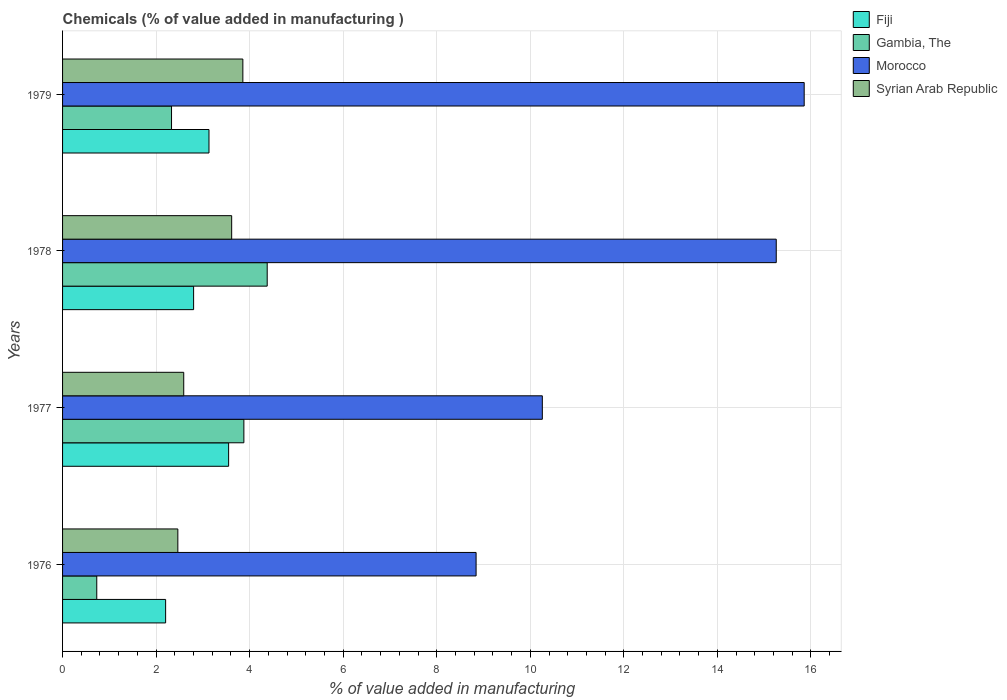How many groups of bars are there?
Give a very brief answer. 4. Are the number of bars on each tick of the Y-axis equal?
Your answer should be compact. Yes. What is the label of the 1st group of bars from the top?
Offer a very short reply. 1979. What is the value added in manufacturing chemicals in Morocco in 1977?
Your answer should be compact. 10.26. Across all years, what is the maximum value added in manufacturing chemicals in Morocco?
Keep it short and to the point. 15.86. Across all years, what is the minimum value added in manufacturing chemicals in Morocco?
Provide a short and direct response. 8.84. In which year was the value added in manufacturing chemicals in Morocco maximum?
Make the answer very short. 1979. In which year was the value added in manufacturing chemicals in Fiji minimum?
Your answer should be compact. 1976. What is the total value added in manufacturing chemicals in Syrian Arab Republic in the graph?
Your answer should be compact. 12.53. What is the difference between the value added in manufacturing chemicals in Gambia, The in 1977 and that in 1979?
Offer a terse response. 1.55. What is the difference between the value added in manufacturing chemicals in Syrian Arab Republic in 1978 and the value added in manufacturing chemicals in Fiji in 1977?
Your answer should be compact. 0.07. What is the average value added in manufacturing chemicals in Gambia, The per year?
Your answer should be compact. 2.83. In the year 1977, what is the difference between the value added in manufacturing chemicals in Morocco and value added in manufacturing chemicals in Syrian Arab Republic?
Provide a succinct answer. 7.67. What is the ratio of the value added in manufacturing chemicals in Gambia, The in 1977 to that in 1979?
Offer a very short reply. 1.66. What is the difference between the highest and the second highest value added in manufacturing chemicals in Syrian Arab Republic?
Your answer should be compact. 0.24. What is the difference between the highest and the lowest value added in manufacturing chemicals in Fiji?
Offer a terse response. 1.35. In how many years, is the value added in manufacturing chemicals in Fiji greater than the average value added in manufacturing chemicals in Fiji taken over all years?
Keep it short and to the point. 2. Is the sum of the value added in manufacturing chemicals in Fiji in 1976 and 1977 greater than the maximum value added in manufacturing chemicals in Gambia, The across all years?
Your answer should be compact. Yes. Is it the case that in every year, the sum of the value added in manufacturing chemicals in Fiji and value added in manufacturing chemicals in Syrian Arab Republic is greater than the sum of value added in manufacturing chemicals in Morocco and value added in manufacturing chemicals in Gambia, The?
Ensure brevity in your answer.  No. What does the 2nd bar from the top in 1977 represents?
Offer a very short reply. Morocco. What does the 2nd bar from the bottom in 1977 represents?
Ensure brevity in your answer.  Gambia, The. Is it the case that in every year, the sum of the value added in manufacturing chemicals in Syrian Arab Republic and value added in manufacturing chemicals in Fiji is greater than the value added in manufacturing chemicals in Morocco?
Your response must be concise. No. How many years are there in the graph?
Keep it short and to the point. 4. Where does the legend appear in the graph?
Keep it short and to the point. Top right. How are the legend labels stacked?
Offer a very short reply. Vertical. What is the title of the graph?
Offer a very short reply. Chemicals (% of value added in manufacturing ). What is the label or title of the X-axis?
Give a very brief answer. % of value added in manufacturing. What is the label or title of the Y-axis?
Offer a very short reply. Years. What is the % of value added in manufacturing in Fiji in 1976?
Provide a short and direct response. 2.2. What is the % of value added in manufacturing in Gambia, The in 1976?
Give a very brief answer. 0.73. What is the % of value added in manufacturing in Morocco in 1976?
Ensure brevity in your answer.  8.84. What is the % of value added in manufacturing of Syrian Arab Republic in 1976?
Provide a short and direct response. 2.46. What is the % of value added in manufacturing of Fiji in 1977?
Provide a succinct answer. 3.55. What is the % of value added in manufacturing in Gambia, The in 1977?
Ensure brevity in your answer.  3.88. What is the % of value added in manufacturing of Morocco in 1977?
Make the answer very short. 10.26. What is the % of value added in manufacturing of Syrian Arab Republic in 1977?
Your answer should be compact. 2.59. What is the % of value added in manufacturing in Fiji in 1978?
Ensure brevity in your answer.  2.8. What is the % of value added in manufacturing of Gambia, The in 1978?
Provide a succinct answer. 4.38. What is the % of value added in manufacturing of Morocco in 1978?
Your answer should be compact. 15.26. What is the % of value added in manufacturing of Syrian Arab Republic in 1978?
Ensure brevity in your answer.  3.62. What is the % of value added in manufacturing in Fiji in 1979?
Provide a succinct answer. 3.13. What is the % of value added in manufacturing of Gambia, The in 1979?
Provide a short and direct response. 2.33. What is the % of value added in manufacturing of Morocco in 1979?
Make the answer very short. 15.86. What is the % of value added in manufacturing in Syrian Arab Republic in 1979?
Keep it short and to the point. 3.85. Across all years, what is the maximum % of value added in manufacturing in Fiji?
Offer a very short reply. 3.55. Across all years, what is the maximum % of value added in manufacturing in Gambia, The?
Your answer should be compact. 4.38. Across all years, what is the maximum % of value added in manufacturing of Morocco?
Ensure brevity in your answer.  15.86. Across all years, what is the maximum % of value added in manufacturing of Syrian Arab Republic?
Give a very brief answer. 3.85. Across all years, what is the minimum % of value added in manufacturing in Fiji?
Provide a succinct answer. 2.2. Across all years, what is the minimum % of value added in manufacturing in Gambia, The?
Offer a very short reply. 0.73. Across all years, what is the minimum % of value added in manufacturing in Morocco?
Provide a short and direct response. 8.84. Across all years, what is the minimum % of value added in manufacturing in Syrian Arab Republic?
Provide a succinct answer. 2.46. What is the total % of value added in manufacturing of Fiji in the graph?
Your response must be concise. 11.69. What is the total % of value added in manufacturing in Gambia, The in the graph?
Provide a succinct answer. 11.31. What is the total % of value added in manufacturing in Morocco in the graph?
Keep it short and to the point. 50.21. What is the total % of value added in manufacturing in Syrian Arab Republic in the graph?
Give a very brief answer. 12.53. What is the difference between the % of value added in manufacturing in Fiji in 1976 and that in 1977?
Offer a very short reply. -1.35. What is the difference between the % of value added in manufacturing of Gambia, The in 1976 and that in 1977?
Provide a succinct answer. -3.15. What is the difference between the % of value added in manufacturing of Morocco in 1976 and that in 1977?
Your answer should be compact. -1.42. What is the difference between the % of value added in manufacturing of Syrian Arab Republic in 1976 and that in 1977?
Offer a very short reply. -0.13. What is the difference between the % of value added in manufacturing of Fiji in 1976 and that in 1978?
Provide a succinct answer. -0.6. What is the difference between the % of value added in manufacturing in Gambia, The in 1976 and that in 1978?
Ensure brevity in your answer.  -3.64. What is the difference between the % of value added in manufacturing in Morocco in 1976 and that in 1978?
Provide a succinct answer. -6.42. What is the difference between the % of value added in manufacturing in Syrian Arab Republic in 1976 and that in 1978?
Ensure brevity in your answer.  -1.15. What is the difference between the % of value added in manufacturing in Fiji in 1976 and that in 1979?
Your response must be concise. -0.93. What is the difference between the % of value added in manufacturing of Gambia, The in 1976 and that in 1979?
Provide a succinct answer. -1.6. What is the difference between the % of value added in manufacturing in Morocco in 1976 and that in 1979?
Your response must be concise. -7.01. What is the difference between the % of value added in manufacturing in Syrian Arab Republic in 1976 and that in 1979?
Provide a short and direct response. -1.39. What is the difference between the % of value added in manufacturing in Fiji in 1977 and that in 1978?
Make the answer very short. 0.75. What is the difference between the % of value added in manufacturing of Gambia, The in 1977 and that in 1978?
Your response must be concise. -0.5. What is the difference between the % of value added in manufacturing of Morocco in 1977 and that in 1978?
Keep it short and to the point. -5. What is the difference between the % of value added in manufacturing in Syrian Arab Republic in 1977 and that in 1978?
Keep it short and to the point. -1.02. What is the difference between the % of value added in manufacturing of Fiji in 1977 and that in 1979?
Keep it short and to the point. 0.42. What is the difference between the % of value added in manufacturing in Gambia, The in 1977 and that in 1979?
Provide a short and direct response. 1.55. What is the difference between the % of value added in manufacturing of Morocco in 1977 and that in 1979?
Offer a very short reply. -5.6. What is the difference between the % of value added in manufacturing in Syrian Arab Republic in 1977 and that in 1979?
Keep it short and to the point. -1.26. What is the difference between the % of value added in manufacturing of Fiji in 1978 and that in 1979?
Give a very brief answer. -0.33. What is the difference between the % of value added in manufacturing of Gambia, The in 1978 and that in 1979?
Give a very brief answer. 2.05. What is the difference between the % of value added in manufacturing in Morocco in 1978 and that in 1979?
Offer a terse response. -0.6. What is the difference between the % of value added in manufacturing of Syrian Arab Republic in 1978 and that in 1979?
Give a very brief answer. -0.24. What is the difference between the % of value added in manufacturing of Fiji in 1976 and the % of value added in manufacturing of Gambia, The in 1977?
Give a very brief answer. -1.67. What is the difference between the % of value added in manufacturing of Fiji in 1976 and the % of value added in manufacturing of Morocco in 1977?
Offer a very short reply. -8.05. What is the difference between the % of value added in manufacturing in Fiji in 1976 and the % of value added in manufacturing in Syrian Arab Republic in 1977?
Offer a terse response. -0.39. What is the difference between the % of value added in manufacturing of Gambia, The in 1976 and the % of value added in manufacturing of Morocco in 1977?
Your response must be concise. -9.53. What is the difference between the % of value added in manufacturing of Gambia, The in 1976 and the % of value added in manufacturing of Syrian Arab Republic in 1977?
Your answer should be compact. -1.86. What is the difference between the % of value added in manufacturing of Morocco in 1976 and the % of value added in manufacturing of Syrian Arab Republic in 1977?
Make the answer very short. 6.25. What is the difference between the % of value added in manufacturing of Fiji in 1976 and the % of value added in manufacturing of Gambia, The in 1978?
Offer a very short reply. -2.17. What is the difference between the % of value added in manufacturing in Fiji in 1976 and the % of value added in manufacturing in Morocco in 1978?
Give a very brief answer. -13.06. What is the difference between the % of value added in manufacturing in Fiji in 1976 and the % of value added in manufacturing in Syrian Arab Republic in 1978?
Give a very brief answer. -1.41. What is the difference between the % of value added in manufacturing in Gambia, The in 1976 and the % of value added in manufacturing in Morocco in 1978?
Your answer should be compact. -14.53. What is the difference between the % of value added in manufacturing in Gambia, The in 1976 and the % of value added in manufacturing in Syrian Arab Republic in 1978?
Keep it short and to the point. -2.88. What is the difference between the % of value added in manufacturing in Morocco in 1976 and the % of value added in manufacturing in Syrian Arab Republic in 1978?
Your response must be concise. 5.23. What is the difference between the % of value added in manufacturing in Fiji in 1976 and the % of value added in manufacturing in Gambia, The in 1979?
Offer a very short reply. -0.13. What is the difference between the % of value added in manufacturing of Fiji in 1976 and the % of value added in manufacturing of Morocco in 1979?
Provide a succinct answer. -13.65. What is the difference between the % of value added in manufacturing in Fiji in 1976 and the % of value added in manufacturing in Syrian Arab Republic in 1979?
Keep it short and to the point. -1.65. What is the difference between the % of value added in manufacturing in Gambia, The in 1976 and the % of value added in manufacturing in Morocco in 1979?
Give a very brief answer. -15.12. What is the difference between the % of value added in manufacturing of Gambia, The in 1976 and the % of value added in manufacturing of Syrian Arab Republic in 1979?
Provide a short and direct response. -3.12. What is the difference between the % of value added in manufacturing in Morocco in 1976 and the % of value added in manufacturing in Syrian Arab Republic in 1979?
Offer a terse response. 4.99. What is the difference between the % of value added in manufacturing of Fiji in 1977 and the % of value added in manufacturing of Gambia, The in 1978?
Your answer should be compact. -0.82. What is the difference between the % of value added in manufacturing in Fiji in 1977 and the % of value added in manufacturing in Morocco in 1978?
Your answer should be very brief. -11.71. What is the difference between the % of value added in manufacturing in Fiji in 1977 and the % of value added in manufacturing in Syrian Arab Republic in 1978?
Your answer should be very brief. -0.07. What is the difference between the % of value added in manufacturing in Gambia, The in 1977 and the % of value added in manufacturing in Morocco in 1978?
Your answer should be compact. -11.38. What is the difference between the % of value added in manufacturing in Gambia, The in 1977 and the % of value added in manufacturing in Syrian Arab Republic in 1978?
Provide a short and direct response. 0.26. What is the difference between the % of value added in manufacturing in Morocco in 1977 and the % of value added in manufacturing in Syrian Arab Republic in 1978?
Your answer should be compact. 6.64. What is the difference between the % of value added in manufacturing of Fiji in 1977 and the % of value added in manufacturing of Gambia, The in 1979?
Make the answer very short. 1.22. What is the difference between the % of value added in manufacturing in Fiji in 1977 and the % of value added in manufacturing in Morocco in 1979?
Give a very brief answer. -12.31. What is the difference between the % of value added in manufacturing in Fiji in 1977 and the % of value added in manufacturing in Syrian Arab Republic in 1979?
Make the answer very short. -0.3. What is the difference between the % of value added in manufacturing of Gambia, The in 1977 and the % of value added in manufacturing of Morocco in 1979?
Give a very brief answer. -11.98. What is the difference between the % of value added in manufacturing of Gambia, The in 1977 and the % of value added in manufacturing of Syrian Arab Republic in 1979?
Your answer should be compact. 0.02. What is the difference between the % of value added in manufacturing in Morocco in 1977 and the % of value added in manufacturing in Syrian Arab Republic in 1979?
Make the answer very short. 6.4. What is the difference between the % of value added in manufacturing of Fiji in 1978 and the % of value added in manufacturing of Gambia, The in 1979?
Offer a very short reply. 0.47. What is the difference between the % of value added in manufacturing in Fiji in 1978 and the % of value added in manufacturing in Morocco in 1979?
Your answer should be very brief. -13.05. What is the difference between the % of value added in manufacturing of Fiji in 1978 and the % of value added in manufacturing of Syrian Arab Republic in 1979?
Your answer should be very brief. -1.05. What is the difference between the % of value added in manufacturing of Gambia, The in 1978 and the % of value added in manufacturing of Morocco in 1979?
Make the answer very short. -11.48. What is the difference between the % of value added in manufacturing of Gambia, The in 1978 and the % of value added in manufacturing of Syrian Arab Republic in 1979?
Offer a terse response. 0.52. What is the difference between the % of value added in manufacturing of Morocco in 1978 and the % of value added in manufacturing of Syrian Arab Republic in 1979?
Ensure brevity in your answer.  11.4. What is the average % of value added in manufacturing in Fiji per year?
Your response must be concise. 2.92. What is the average % of value added in manufacturing of Gambia, The per year?
Keep it short and to the point. 2.83. What is the average % of value added in manufacturing in Morocco per year?
Keep it short and to the point. 12.55. What is the average % of value added in manufacturing in Syrian Arab Republic per year?
Ensure brevity in your answer.  3.13. In the year 1976, what is the difference between the % of value added in manufacturing in Fiji and % of value added in manufacturing in Gambia, The?
Provide a short and direct response. 1.47. In the year 1976, what is the difference between the % of value added in manufacturing of Fiji and % of value added in manufacturing of Morocco?
Make the answer very short. -6.64. In the year 1976, what is the difference between the % of value added in manufacturing of Fiji and % of value added in manufacturing of Syrian Arab Republic?
Offer a terse response. -0.26. In the year 1976, what is the difference between the % of value added in manufacturing in Gambia, The and % of value added in manufacturing in Morocco?
Offer a terse response. -8.11. In the year 1976, what is the difference between the % of value added in manufacturing in Gambia, The and % of value added in manufacturing in Syrian Arab Republic?
Give a very brief answer. -1.73. In the year 1976, what is the difference between the % of value added in manufacturing of Morocco and % of value added in manufacturing of Syrian Arab Republic?
Keep it short and to the point. 6.38. In the year 1977, what is the difference between the % of value added in manufacturing of Fiji and % of value added in manufacturing of Gambia, The?
Your response must be concise. -0.33. In the year 1977, what is the difference between the % of value added in manufacturing of Fiji and % of value added in manufacturing of Morocco?
Offer a very short reply. -6.71. In the year 1977, what is the difference between the % of value added in manufacturing of Fiji and % of value added in manufacturing of Syrian Arab Republic?
Offer a terse response. 0.96. In the year 1977, what is the difference between the % of value added in manufacturing of Gambia, The and % of value added in manufacturing of Morocco?
Provide a succinct answer. -6.38. In the year 1977, what is the difference between the % of value added in manufacturing in Gambia, The and % of value added in manufacturing in Syrian Arab Republic?
Give a very brief answer. 1.29. In the year 1977, what is the difference between the % of value added in manufacturing in Morocco and % of value added in manufacturing in Syrian Arab Republic?
Make the answer very short. 7.67. In the year 1978, what is the difference between the % of value added in manufacturing in Fiji and % of value added in manufacturing in Gambia, The?
Your answer should be compact. -1.57. In the year 1978, what is the difference between the % of value added in manufacturing of Fiji and % of value added in manufacturing of Morocco?
Provide a succinct answer. -12.46. In the year 1978, what is the difference between the % of value added in manufacturing in Fiji and % of value added in manufacturing in Syrian Arab Republic?
Make the answer very short. -0.81. In the year 1978, what is the difference between the % of value added in manufacturing of Gambia, The and % of value added in manufacturing of Morocco?
Keep it short and to the point. -10.88. In the year 1978, what is the difference between the % of value added in manufacturing of Gambia, The and % of value added in manufacturing of Syrian Arab Republic?
Your answer should be compact. 0.76. In the year 1978, what is the difference between the % of value added in manufacturing of Morocco and % of value added in manufacturing of Syrian Arab Republic?
Provide a short and direct response. 11.64. In the year 1979, what is the difference between the % of value added in manufacturing in Fiji and % of value added in manufacturing in Gambia, The?
Give a very brief answer. 0.8. In the year 1979, what is the difference between the % of value added in manufacturing in Fiji and % of value added in manufacturing in Morocco?
Your answer should be compact. -12.73. In the year 1979, what is the difference between the % of value added in manufacturing in Fiji and % of value added in manufacturing in Syrian Arab Republic?
Make the answer very short. -0.72. In the year 1979, what is the difference between the % of value added in manufacturing of Gambia, The and % of value added in manufacturing of Morocco?
Your answer should be very brief. -13.53. In the year 1979, what is the difference between the % of value added in manufacturing in Gambia, The and % of value added in manufacturing in Syrian Arab Republic?
Your response must be concise. -1.53. In the year 1979, what is the difference between the % of value added in manufacturing of Morocco and % of value added in manufacturing of Syrian Arab Republic?
Provide a succinct answer. 12. What is the ratio of the % of value added in manufacturing in Fiji in 1976 to that in 1977?
Provide a succinct answer. 0.62. What is the ratio of the % of value added in manufacturing of Gambia, The in 1976 to that in 1977?
Your response must be concise. 0.19. What is the ratio of the % of value added in manufacturing of Morocco in 1976 to that in 1977?
Your answer should be very brief. 0.86. What is the ratio of the % of value added in manufacturing of Syrian Arab Republic in 1976 to that in 1977?
Your response must be concise. 0.95. What is the ratio of the % of value added in manufacturing in Fiji in 1976 to that in 1978?
Provide a succinct answer. 0.79. What is the ratio of the % of value added in manufacturing in Gambia, The in 1976 to that in 1978?
Your answer should be very brief. 0.17. What is the ratio of the % of value added in manufacturing in Morocco in 1976 to that in 1978?
Offer a very short reply. 0.58. What is the ratio of the % of value added in manufacturing of Syrian Arab Republic in 1976 to that in 1978?
Your answer should be very brief. 0.68. What is the ratio of the % of value added in manufacturing in Fiji in 1976 to that in 1979?
Provide a short and direct response. 0.7. What is the ratio of the % of value added in manufacturing in Gambia, The in 1976 to that in 1979?
Provide a succinct answer. 0.31. What is the ratio of the % of value added in manufacturing of Morocco in 1976 to that in 1979?
Keep it short and to the point. 0.56. What is the ratio of the % of value added in manufacturing in Syrian Arab Republic in 1976 to that in 1979?
Your response must be concise. 0.64. What is the ratio of the % of value added in manufacturing in Fiji in 1977 to that in 1978?
Make the answer very short. 1.27. What is the ratio of the % of value added in manufacturing of Gambia, The in 1977 to that in 1978?
Make the answer very short. 0.89. What is the ratio of the % of value added in manufacturing in Morocco in 1977 to that in 1978?
Provide a succinct answer. 0.67. What is the ratio of the % of value added in manufacturing in Syrian Arab Republic in 1977 to that in 1978?
Ensure brevity in your answer.  0.72. What is the ratio of the % of value added in manufacturing of Fiji in 1977 to that in 1979?
Keep it short and to the point. 1.13. What is the ratio of the % of value added in manufacturing in Gambia, The in 1977 to that in 1979?
Your response must be concise. 1.66. What is the ratio of the % of value added in manufacturing of Morocco in 1977 to that in 1979?
Offer a very short reply. 0.65. What is the ratio of the % of value added in manufacturing in Syrian Arab Republic in 1977 to that in 1979?
Make the answer very short. 0.67. What is the ratio of the % of value added in manufacturing in Fiji in 1978 to that in 1979?
Ensure brevity in your answer.  0.9. What is the ratio of the % of value added in manufacturing of Gambia, The in 1978 to that in 1979?
Your response must be concise. 1.88. What is the ratio of the % of value added in manufacturing of Morocco in 1978 to that in 1979?
Your response must be concise. 0.96. What is the ratio of the % of value added in manufacturing in Syrian Arab Republic in 1978 to that in 1979?
Your answer should be compact. 0.94. What is the difference between the highest and the second highest % of value added in manufacturing of Fiji?
Your answer should be compact. 0.42. What is the difference between the highest and the second highest % of value added in manufacturing in Gambia, The?
Ensure brevity in your answer.  0.5. What is the difference between the highest and the second highest % of value added in manufacturing of Morocco?
Offer a very short reply. 0.6. What is the difference between the highest and the second highest % of value added in manufacturing of Syrian Arab Republic?
Your answer should be very brief. 0.24. What is the difference between the highest and the lowest % of value added in manufacturing in Fiji?
Provide a succinct answer. 1.35. What is the difference between the highest and the lowest % of value added in manufacturing in Gambia, The?
Make the answer very short. 3.64. What is the difference between the highest and the lowest % of value added in manufacturing of Morocco?
Your response must be concise. 7.01. What is the difference between the highest and the lowest % of value added in manufacturing in Syrian Arab Republic?
Provide a succinct answer. 1.39. 